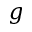<formula> <loc_0><loc_0><loc_500><loc_500>g</formula> 